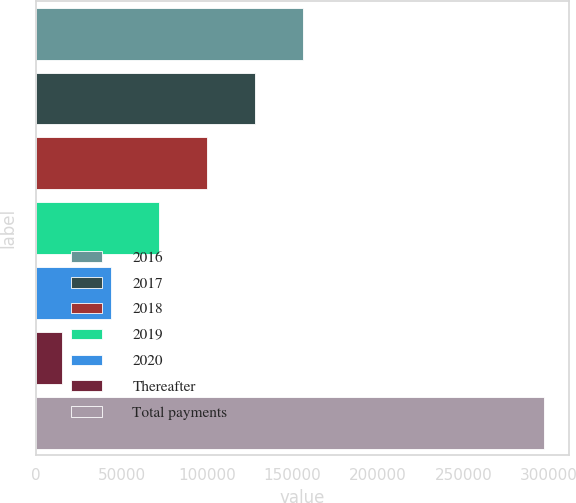Convert chart to OTSL. <chart><loc_0><loc_0><loc_500><loc_500><bar_chart><fcel>2016<fcel>2017<fcel>2018<fcel>2019<fcel>2020<fcel>Thereafter<fcel>Total payments<nl><fcel>156270<fcel>128106<fcel>99943.3<fcel>71780.2<fcel>43617.1<fcel>15454<fcel>297085<nl></chart> 